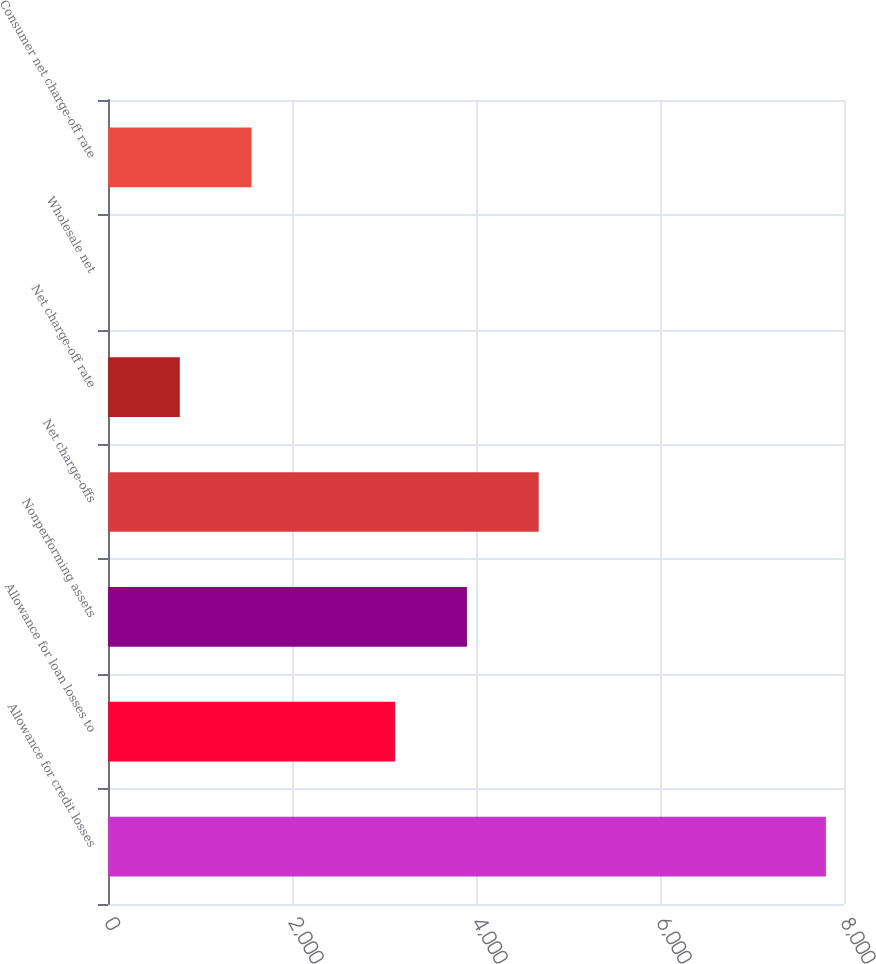Convert chart to OTSL. <chart><loc_0><loc_0><loc_500><loc_500><bar_chart><fcel>Allowance for credit losses<fcel>Allowance for loan losses to<fcel>Nonperforming assets<fcel>Net charge-offs<fcel>Net charge-off rate<fcel>Wholesale net<fcel>Consumer net charge-off rate<nl><fcel>7803<fcel>3121.21<fcel>3901.51<fcel>4681.81<fcel>780.31<fcel>0.01<fcel>1560.61<nl></chart> 